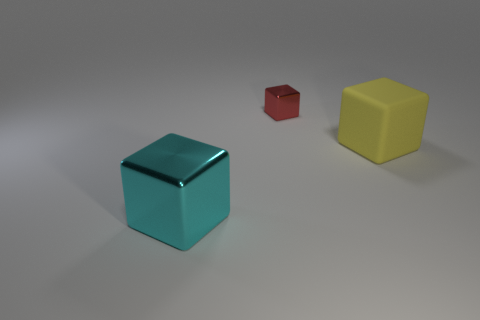There is a metallic object that is behind the big metallic cube; is it the same shape as the big cyan thing?
Provide a succinct answer. Yes. Is there any other thing that has the same material as the yellow block?
Your answer should be compact. No. There is a red block; is its size the same as the cube that is in front of the big rubber thing?
Provide a short and direct response. No. What number of other things are there of the same color as the large metal block?
Keep it short and to the point. 0. There is a big yellow matte object; are there any metal things in front of it?
Provide a succinct answer. Yes. How many objects are either yellow metallic cylinders or shiny objects behind the matte object?
Your answer should be very brief. 1. Is there a large metal object that is to the right of the shiny block that is in front of the small shiny cube?
Give a very brief answer. No. What is the shape of the red shiny thing to the right of the shiny object that is in front of the metal thing that is behind the cyan cube?
Ensure brevity in your answer.  Cube. There is a block that is both left of the yellow matte object and right of the cyan object; what is its color?
Ensure brevity in your answer.  Red. What shape is the large object to the right of the big cyan block?
Give a very brief answer. Cube. 